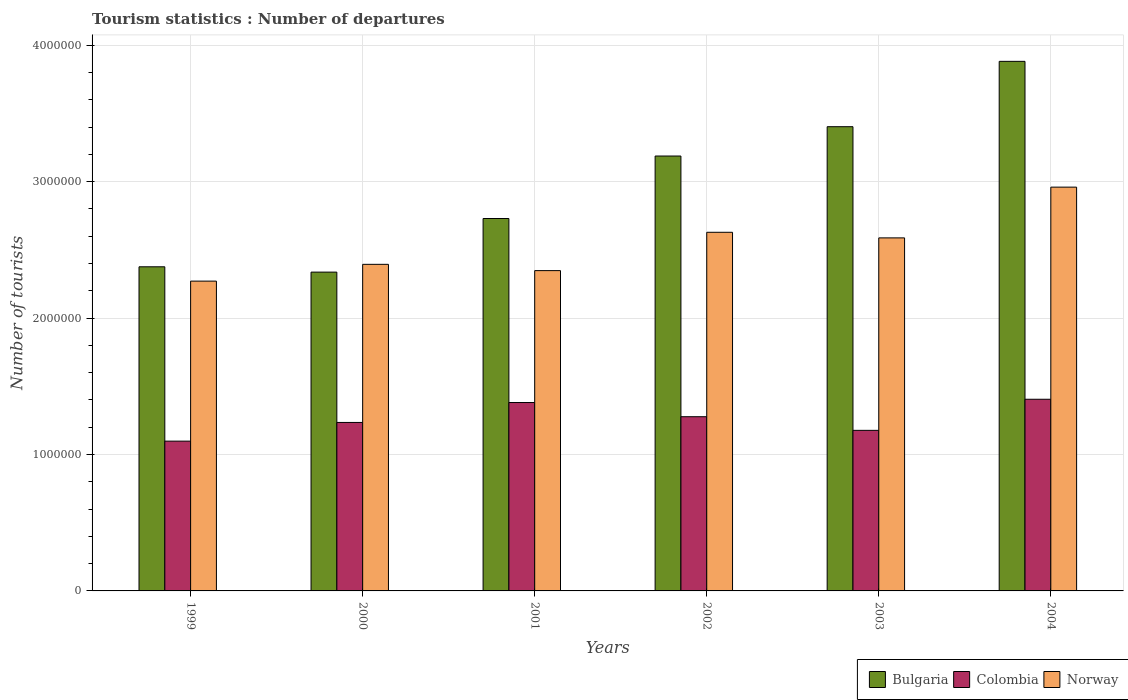Are the number of bars per tick equal to the number of legend labels?
Ensure brevity in your answer.  Yes. How many bars are there on the 6th tick from the left?
Give a very brief answer. 3. What is the label of the 6th group of bars from the left?
Offer a very short reply. 2004. What is the number of tourist departures in Colombia in 2003?
Your answer should be very brief. 1.18e+06. Across all years, what is the maximum number of tourist departures in Colombia?
Ensure brevity in your answer.  1.40e+06. Across all years, what is the minimum number of tourist departures in Norway?
Give a very brief answer. 2.27e+06. In which year was the number of tourist departures in Norway maximum?
Keep it short and to the point. 2004. What is the total number of tourist departures in Bulgaria in the graph?
Make the answer very short. 1.79e+07. What is the difference between the number of tourist departures in Colombia in 1999 and that in 2004?
Keep it short and to the point. -3.07e+05. What is the difference between the number of tourist departures in Colombia in 2002 and the number of tourist departures in Bulgaria in 2004?
Ensure brevity in your answer.  -2.60e+06. What is the average number of tourist departures in Bulgaria per year?
Your answer should be compact. 2.99e+06. In the year 2003, what is the difference between the number of tourist departures in Norway and number of tourist departures in Bulgaria?
Offer a very short reply. -8.15e+05. In how many years, is the number of tourist departures in Colombia greater than 3200000?
Your answer should be very brief. 0. What is the ratio of the number of tourist departures in Norway in 1999 to that in 2001?
Offer a terse response. 0.97. What is the difference between the highest and the second highest number of tourist departures in Colombia?
Ensure brevity in your answer.  2.40e+04. What is the difference between the highest and the lowest number of tourist departures in Norway?
Give a very brief answer. 6.89e+05. Is the sum of the number of tourist departures in Norway in 2003 and 2004 greater than the maximum number of tourist departures in Colombia across all years?
Your answer should be compact. Yes. What does the 2nd bar from the right in 1999 represents?
Offer a very short reply. Colombia. Is it the case that in every year, the sum of the number of tourist departures in Norway and number of tourist departures in Colombia is greater than the number of tourist departures in Bulgaria?
Provide a short and direct response. Yes. How many bars are there?
Provide a succinct answer. 18. Are all the bars in the graph horizontal?
Provide a short and direct response. No. Are the values on the major ticks of Y-axis written in scientific E-notation?
Give a very brief answer. No. Does the graph contain any zero values?
Give a very brief answer. No. Does the graph contain grids?
Your answer should be very brief. Yes. Where does the legend appear in the graph?
Offer a terse response. Bottom right. How are the legend labels stacked?
Your response must be concise. Horizontal. What is the title of the graph?
Offer a terse response. Tourism statistics : Number of departures. Does "Cayman Islands" appear as one of the legend labels in the graph?
Offer a terse response. No. What is the label or title of the Y-axis?
Ensure brevity in your answer.  Number of tourists. What is the Number of tourists in Bulgaria in 1999?
Make the answer very short. 2.38e+06. What is the Number of tourists of Colombia in 1999?
Ensure brevity in your answer.  1.10e+06. What is the Number of tourists of Norway in 1999?
Your answer should be very brief. 2.27e+06. What is the Number of tourists of Bulgaria in 2000?
Provide a succinct answer. 2.34e+06. What is the Number of tourists of Colombia in 2000?
Ensure brevity in your answer.  1.24e+06. What is the Number of tourists of Norway in 2000?
Make the answer very short. 2.39e+06. What is the Number of tourists in Bulgaria in 2001?
Provide a succinct answer. 2.73e+06. What is the Number of tourists in Colombia in 2001?
Your answer should be very brief. 1.38e+06. What is the Number of tourists of Norway in 2001?
Ensure brevity in your answer.  2.35e+06. What is the Number of tourists of Bulgaria in 2002?
Give a very brief answer. 3.19e+06. What is the Number of tourists in Colombia in 2002?
Make the answer very short. 1.28e+06. What is the Number of tourists of Norway in 2002?
Your answer should be very brief. 2.63e+06. What is the Number of tourists of Bulgaria in 2003?
Make the answer very short. 3.40e+06. What is the Number of tourists in Colombia in 2003?
Offer a very short reply. 1.18e+06. What is the Number of tourists in Norway in 2003?
Your answer should be very brief. 2.59e+06. What is the Number of tourists of Bulgaria in 2004?
Provide a short and direct response. 3.88e+06. What is the Number of tourists in Colombia in 2004?
Provide a succinct answer. 1.40e+06. What is the Number of tourists in Norway in 2004?
Your answer should be very brief. 2.96e+06. Across all years, what is the maximum Number of tourists of Bulgaria?
Keep it short and to the point. 3.88e+06. Across all years, what is the maximum Number of tourists in Colombia?
Your response must be concise. 1.40e+06. Across all years, what is the maximum Number of tourists in Norway?
Your response must be concise. 2.96e+06. Across all years, what is the minimum Number of tourists of Bulgaria?
Provide a short and direct response. 2.34e+06. Across all years, what is the minimum Number of tourists in Colombia?
Make the answer very short. 1.10e+06. Across all years, what is the minimum Number of tourists of Norway?
Give a very brief answer. 2.27e+06. What is the total Number of tourists of Bulgaria in the graph?
Offer a terse response. 1.79e+07. What is the total Number of tourists of Colombia in the graph?
Give a very brief answer. 7.57e+06. What is the total Number of tourists in Norway in the graph?
Keep it short and to the point. 1.52e+07. What is the difference between the Number of tourists of Bulgaria in 1999 and that in 2000?
Ensure brevity in your answer.  3.90e+04. What is the difference between the Number of tourists of Colombia in 1999 and that in 2000?
Offer a terse response. -1.37e+05. What is the difference between the Number of tourists of Norway in 1999 and that in 2000?
Ensure brevity in your answer.  -1.23e+05. What is the difference between the Number of tourists in Bulgaria in 1999 and that in 2001?
Your answer should be compact. -3.54e+05. What is the difference between the Number of tourists of Colombia in 1999 and that in 2001?
Your answer should be very brief. -2.83e+05. What is the difference between the Number of tourists in Norway in 1999 and that in 2001?
Give a very brief answer. -7.70e+04. What is the difference between the Number of tourists in Bulgaria in 1999 and that in 2002?
Provide a succinct answer. -8.12e+05. What is the difference between the Number of tourists of Colombia in 1999 and that in 2002?
Your response must be concise. -1.79e+05. What is the difference between the Number of tourists of Norway in 1999 and that in 2002?
Keep it short and to the point. -3.58e+05. What is the difference between the Number of tourists of Bulgaria in 1999 and that in 2003?
Your answer should be compact. -1.03e+06. What is the difference between the Number of tourists in Colombia in 1999 and that in 2003?
Give a very brief answer. -7.90e+04. What is the difference between the Number of tourists of Norway in 1999 and that in 2003?
Make the answer very short. -3.17e+05. What is the difference between the Number of tourists in Bulgaria in 1999 and that in 2004?
Your answer should be compact. -1.51e+06. What is the difference between the Number of tourists in Colombia in 1999 and that in 2004?
Give a very brief answer. -3.07e+05. What is the difference between the Number of tourists in Norway in 1999 and that in 2004?
Offer a very short reply. -6.89e+05. What is the difference between the Number of tourists of Bulgaria in 2000 and that in 2001?
Keep it short and to the point. -3.93e+05. What is the difference between the Number of tourists in Colombia in 2000 and that in 2001?
Your response must be concise. -1.46e+05. What is the difference between the Number of tourists of Norway in 2000 and that in 2001?
Make the answer very short. 4.60e+04. What is the difference between the Number of tourists of Bulgaria in 2000 and that in 2002?
Give a very brief answer. -8.51e+05. What is the difference between the Number of tourists in Colombia in 2000 and that in 2002?
Offer a terse response. -4.20e+04. What is the difference between the Number of tourists of Norway in 2000 and that in 2002?
Your answer should be very brief. -2.35e+05. What is the difference between the Number of tourists of Bulgaria in 2000 and that in 2003?
Provide a short and direct response. -1.07e+06. What is the difference between the Number of tourists of Colombia in 2000 and that in 2003?
Give a very brief answer. 5.80e+04. What is the difference between the Number of tourists in Norway in 2000 and that in 2003?
Ensure brevity in your answer.  -1.94e+05. What is the difference between the Number of tourists in Bulgaria in 2000 and that in 2004?
Keep it short and to the point. -1.54e+06. What is the difference between the Number of tourists of Norway in 2000 and that in 2004?
Provide a short and direct response. -5.66e+05. What is the difference between the Number of tourists in Bulgaria in 2001 and that in 2002?
Ensure brevity in your answer.  -4.58e+05. What is the difference between the Number of tourists of Colombia in 2001 and that in 2002?
Your answer should be compact. 1.04e+05. What is the difference between the Number of tourists of Norway in 2001 and that in 2002?
Provide a succinct answer. -2.81e+05. What is the difference between the Number of tourists of Bulgaria in 2001 and that in 2003?
Ensure brevity in your answer.  -6.73e+05. What is the difference between the Number of tourists in Colombia in 2001 and that in 2003?
Keep it short and to the point. 2.04e+05. What is the difference between the Number of tourists of Bulgaria in 2001 and that in 2004?
Provide a succinct answer. -1.15e+06. What is the difference between the Number of tourists of Colombia in 2001 and that in 2004?
Offer a terse response. -2.40e+04. What is the difference between the Number of tourists of Norway in 2001 and that in 2004?
Your answer should be very brief. -6.12e+05. What is the difference between the Number of tourists of Bulgaria in 2002 and that in 2003?
Provide a succinct answer. -2.15e+05. What is the difference between the Number of tourists of Norway in 2002 and that in 2003?
Provide a succinct answer. 4.10e+04. What is the difference between the Number of tourists in Bulgaria in 2002 and that in 2004?
Keep it short and to the point. -6.94e+05. What is the difference between the Number of tourists of Colombia in 2002 and that in 2004?
Give a very brief answer. -1.28e+05. What is the difference between the Number of tourists of Norway in 2002 and that in 2004?
Provide a short and direct response. -3.31e+05. What is the difference between the Number of tourists in Bulgaria in 2003 and that in 2004?
Ensure brevity in your answer.  -4.79e+05. What is the difference between the Number of tourists in Colombia in 2003 and that in 2004?
Provide a succinct answer. -2.28e+05. What is the difference between the Number of tourists in Norway in 2003 and that in 2004?
Your response must be concise. -3.72e+05. What is the difference between the Number of tourists of Bulgaria in 1999 and the Number of tourists of Colombia in 2000?
Offer a very short reply. 1.14e+06. What is the difference between the Number of tourists of Bulgaria in 1999 and the Number of tourists of Norway in 2000?
Offer a very short reply. -1.80e+04. What is the difference between the Number of tourists of Colombia in 1999 and the Number of tourists of Norway in 2000?
Provide a short and direct response. -1.30e+06. What is the difference between the Number of tourists of Bulgaria in 1999 and the Number of tourists of Colombia in 2001?
Your answer should be very brief. 9.95e+05. What is the difference between the Number of tourists in Bulgaria in 1999 and the Number of tourists in Norway in 2001?
Offer a terse response. 2.80e+04. What is the difference between the Number of tourists in Colombia in 1999 and the Number of tourists in Norway in 2001?
Offer a very short reply. -1.25e+06. What is the difference between the Number of tourists of Bulgaria in 1999 and the Number of tourists of Colombia in 2002?
Provide a short and direct response. 1.10e+06. What is the difference between the Number of tourists of Bulgaria in 1999 and the Number of tourists of Norway in 2002?
Your response must be concise. -2.53e+05. What is the difference between the Number of tourists of Colombia in 1999 and the Number of tourists of Norway in 2002?
Keep it short and to the point. -1.53e+06. What is the difference between the Number of tourists in Bulgaria in 1999 and the Number of tourists in Colombia in 2003?
Offer a terse response. 1.20e+06. What is the difference between the Number of tourists in Bulgaria in 1999 and the Number of tourists in Norway in 2003?
Provide a short and direct response. -2.12e+05. What is the difference between the Number of tourists in Colombia in 1999 and the Number of tourists in Norway in 2003?
Your answer should be compact. -1.49e+06. What is the difference between the Number of tourists of Bulgaria in 1999 and the Number of tourists of Colombia in 2004?
Offer a terse response. 9.71e+05. What is the difference between the Number of tourists of Bulgaria in 1999 and the Number of tourists of Norway in 2004?
Offer a very short reply. -5.84e+05. What is the difference between the Number of tourists in Colombia in 1999 and the Number of tourists in Norway in 2004?
Provide a succinct answer. -1.86e+06. What is the difference between the Number of tourists in Bulgaria in 2000 and the Number of tourists in Colombia in 2001?
Your answer should be compact. 9.56e+05. What is the difference between the Number of tourists in Bulgaria in 2000 and the Number of tourists in Norway in 2001?
Your answer should be very brief. -1.10e+04. What is the difference between the Number of tourists in Colombia in 2000 and the Number of tourists in Norway in 2001?
Give a very brief answer. -1.11e+06. What is the difference between the Number of tourists of Bulgaria in 2000 and the Number of tourists of Colombia in 2002?
Provide a succinct answer. 1.06e+06. What is the difference between the Number of tourists of Bulgaria in 2000 and the Number of tourists of Norway in 2002?
Provide a short and direct response. -2.92e+05. What is the difference between the Number of tourists in Colombia in 2000 and the Number of tourists in Norway in 2002?
Provide a short and direct response. -1.39e+06. What is the difference between the Number of tourists of Bulgaria in 2000 and the Number of tourists of Colombia in 2003?
Give a very brief answer. 1.16e+06. What is the difference between the Number of tourists in Bulgaria in 2000 and the Number of tourists in Norway in 2003?
Your answer should be very brief. -2.51e+05. What is the difference between the Number of tourists of Colombia in 2000 and the Number of tourists of Norway in 2003?
Give a very brief answer. -1.35e+06. What is the difference between the Number of tourists of Bulgaria in 2000 and the Number of tourists of Colombia in 2004?
Offer a terse response. 9.32e+05. What is the difference between the Number of tourists of Bulgaria in 2000 and the Number of tourists of Norway in 2004?
Ensure brevity in your answer.  -6.23e+05. What is the difference between the Number of tourists in Colombia in 2000 and the Number of tourists in Norway in 2004?
Provide a short and direct response. -1.72e+06. What is the difference between the Number of tourists in Bulgaria in 2001 and the Number of tourists in Colombia in 2002?
Offer a terse response. 1.45e+06. What is the difference between the Number of tourists of Bulgaria in 2001 and the Number of tourists of Norway in 2002?
Provide a short and direct response. 1.01e+05. What is the difference between the Number of tourists in Colombia in 2001 and the Number of tourists in Norway in 2002?
Make the answer very short. -1.25e+06. What is the difference between the Number of tourists in Bulgaria in 2001 and the Number of tourists in Colombia in 2003?
Ensure brevity in your answer.  1.55e+06. What is the difference between the Number of tourists in Bulgaria in 2001 and the Number of tourists in Norway in 2003?
Offer a very short reply. 1.42e+05. What is the difference between the Number of tourists of Colombia in 2001 and the Number of tourists of Norway in 2003?
Offer a terse response. -1.21e+06. What is the difference between the Number of tourists in Bulgaria in 2001 and the Number of tourists in Colombia in 2004?
Keep it short and to the point. 1.32e+06. What is the difference between the Number of tourists in Colombia in 2001 and the Number of tourists in Norway in 2004?
Your response must be concise. -1.58e+06. What is the difference between the Number of tourists of Bulgaria in 2002 and the Number of tourists of Colombia in 2003?
Give a very brief answer. 2.01e+06. What is the difference between the Number of tourists in Bulgaria in 2002 and the Number of tourists in Norway in 2003?
Offer a terse response. 6.00e+05. What is the difference between the Number of tourists in Colombia in 2002 and the Number of tourists in Norway in 2003?
Provide a succinct answer. -1.31e+06. What is the difference between the Number of tourists of Bulgaria in 2002 and the Number of tourists of Colombia in 2004?
Keep it short and to the point. 1.78e+06. What is the difference between the Number of tourists of Bulgaria in 2002 and the Number of tourists of Norway in 2004?
Offer a very short reply. 2.28e+05. What is the difference between the Number of tourists in Colombia in 2002 and the Number of tourists in Norway in 2004?
Provide a short and direct response. -1.68e+06. What is the difference between the Number of tourists of Bulgaria in 2003 and the Number of tourists of Colombia in 2004?
Provide a succinct answer. 2.00e+06. What is the difference between the Number of tourists in Bulgaria in 2003 and the Number of tourists in Norway in 2004?
Your answer should be very brief. 4.43e+05. What is the difference between the Number of tourists of Colombia in 2003 and the Number of tourists of Norway in 2004?
Your response must be concise. -1.78e+06. What is the average Number of tourists of Bulgaria per year?
Provide a short and direct response. 2.99e+06. What is the average Number of tourists of Colombia per year?
Provide a succinct answer. 1.26e+06. What is the average Number of tourists of Norway per year?
Provide a short and direct response. 2.53e+06. In the year 1999, what is the difference between the Number of tourists in Bulgaria and Number of tourists in Colombia?
Provide a short and direct response. 1.28e+06. In the year 1999, what is the difference between the Number of tourists in Bulgaria and Number of tourists in Norway?
Offer a very short reply. 1.05e+05. In the year 1999, what is the difference between the Number of tourists of Colombia and Number of tourists of Norway?
Provide a short and direct response. -1.17e+06. In the year 2000, what is the difference between the Number of tourists in Bulgaria and Number of tourists in Colombia?
Your response must be concise. 1.10e+06. In the year 2000, what is the difference between the Number of tourists of Bulgaria and Number of tourists of Norway?
Offer a very short reply. -5.70e+04. In the year 2000, what is the difference between the Number of tourists in Colombia and Number of tourists in Norway?
Provide a succinct answer. -1.16e+06. In the year 2001, what is the difference between the Number of tourists of Bulgaria and Number of tourists of Colombia?
Offer a very short reply. 1.35e+06. In the year 2001, what is the difference between the Number of tourists in Bulgaria and Number of tourists in Norway?
Give a very brief answer. 3.82e+05. In the year 2001, what is the difference between the Number of tourists in Colombia and Number of tourists in Norway?
Provide a short and direct response. -9.67e+05. In the year 2002, what is the difference between the Number of tourists of Bulgaria and Number of tourists of Colombia?
Offer a terse response. 1.91e+06. In the year 2002, what is the difference between the Number of tourists in Bulgaria and Number of tourists in Norway?
Your response must be concise. 5.59e+05. In the year 2002, what is the difference between the Number of tourists in Colombia and Number of tourists in Norway?
Keep it short and to the point. -1.35e+06. In the year 2003, what is the difference between the Number of tourists in Bulgaria and Number of tourists in Colombia?
Keep it short and to the point. 2.23e+06. In the year 2003, what is the difference between the Number of tourists in Bulgaria and Number of tourists in Norway?
Your answer should be compact. 8.15e+05. In the year 2003, what is the difference between the Number of tourists in Colombia and Number of tourists in Norway?
Make the answer very short. -1.41e+06. In the year 2004, what is the difference between the Number of tourists in Bulgaria and Number of tourists in Colombia?
Ensure brevity in your answer.  2.48e+06. In the year 2004, what is the difference between the Number of tourists in Bulgaria and Number of tourists in Norway?
Offer a terse response. 9.22e+05. In the year 2004, what is the difference between the Number of tourists of Colombia and Number of tourists of Norway?
Your answer should be very brief. -1.56e+06. What is the ratio of the Number of tourists of Bulgaria in 1999 to that in 2000?
Offer a very short reply. 1.02. What is the ratio of the Number of tourists in Colombia in 1999 to that in 2000?
Give a very brief answer. 0.89. What is the ratio of the Number of tourists of Norway in 1999 to that in 2000?
Your response must be concise. 0.95. What is the ratio of the Number of tourists of Bulgaria in 1999 to that in 2001?
Ensure brevity in your answer.  0.87. What is the ratio of the Number of tourists in Colombia in 1999 to that in 2001?
Offer a very short reply. 0.8. What is the ratio of the Number of tourists in Norway in 1999 to that in 2001?
Provide a succinct answer. 0.97. What is the ratio of the Number of tourists of Bulgaria in 1999 to that in 2002?
Ensure brevity in your answer.  0.75. What is the ratio of the Number of tourists in Colombia in 1999 to that in 2002?
Provide a succinct answer. 0.86. What is the ratio of the Number of tourists of Norway in 1999 to that in 2002?
Offer a terse response. 0.86. What is the ratio of the Number of tourists of Bulgaria in 1999 to that in 2003?
Make the answer very short. 0.7. What is the ratio of the Number of tourists in Colombia in 1999 to that in 2003?
Keep it short and to the point. 0.93. What is the ratio of the Number of tourists in Norway in 1999 to that in 2003?
Give a very brief answer. 0.88. What is the ratio of the Number of tourists in Bulgaria in 1999 to that in 2004?
Ensure brevity in your answer.  0.61. What is the ratio of the Number of tourists of Colombia in 1999 to that in 2004?
Offer a terse response. 0.78. What is the ratio of the Number of tourists of Norway in 1999 to that in 2004?
Provide a succinct answer. 0.77. What is the ratio of the Number of tourists in Bulgaria in 2000 to that in 2001?
Offer a terse response. 0.86. What is the ratio of the Number of tourists of Colombia in 2000 to that in 2001?
Ensure brevity in your answer.  0.89. What is the ratio of the Number of tourists of Norway in 2000 to that in 2001?
Make the answer very short. 1.02. What is the ratio of the Number of tourists in Bulgaria in 2000 to that in 2002?
Keep it short and to the point. 0.73. What is the ratio of the Number of tourists in Colombia in 2000 to that in 2002?
Your answer should be very brief. 0.97. What is the ratio of the Number of tourists in Norway in 2000 to that in 2002?
Your response must be concise. 0.91. What is the ratio of the Number of tourists in Bulgaria in 2000 to that in 2003?
Give a very brief answer. 0.69. What is the ratio of the Number of tourists in Colombia in 2000 to that in 2003?
Provide a succinct answer. 1.05. What is the ratio of the Number of tourists in Norway in 2000 to that in 2003?
Offer a terse response. 0.93. What is the ratio of the Number of tourists in Bulgaria in 2000 to that in 2004?
Offer a terse response. 0.6. What is the ratio of the Number of tourists of Colombia in 2000 to that in 2004?
Provide a short and direct response. 0.88. What is the ratio of the Number of tourists of Norway in 2000 to that in 2004?
Ensure brevity in your answer.  0.81. What is the ratio of the Number of tourists in Bulgaria in 2001 to that in 2002?
Your answer should be very brief. 0.86. What is the ratio of the Number of tourists in Colombia in 2001 to that in 2002?
Keep it short and to the point. 1.08. What is the ratio of the Number of tourists in Norway in 2001 to that in 2002?
Your answer should be compact. 0.89. What is the ratio of the Number of tourists of Bulgaria in 2001 to that in 2003?
Your answer should be very brief. 0.8. What is the ratio of the Number of tourists of Colombia in 2001 to that in 2003?
Your answer should be very brief. 1.17. What is the ratio of the Number of tourists in Norway in 2001 to that in 2003?
Offer a very short reply. 0.91. What is the ratio of the Number of tourists in Bulgaria in 2001 to that in 2004?
Keep it short and to the point. 0.7. What is the ratio of the Number of tourists of Colombia in 2001 to that in 2004?
Ensure brevity in your answer.  0.98. What is the ratio of the Number of tourists of Norway in 2001 to that in 2004?
Offer a terse response. 0.79. What is the ratio of the Number of tourists in Bulgaria in 2002 to that in 2003?
Your answer should be compact. 0.94. What is the ratio of the Number of tourists in Colombia in 2002 to that in 2003?
Offer a terse response. 1.08. What is the ratio of the Number of tourists of Norway in 2002 to that in 2003?
Keep it short and to the point. 1.02. What is the ratio of the Number of tourists in Bulgaria in 2002 to that in 2004?
Your answer should be very brief. 0.82. What is the ratio of the Number of tourists in Colombia in 2002 to that in 2004?
Ensure brevity in your answer.  0.91. What is the ratio of the Number of tourists of Norway in 2002 to that in 2004?
Provide a short and direct response. 0.89. What is the ratio of the Number of tourists in Bulgaria in 2003 to that in 2004?
Ensure brevity in your answer.  0.88. What is the ratio of the Number of tourists in Colombia in 2003 to that in 2004?
Your answer should be compact. 0.84. What is the ratio of the Number of tourists of Norway in 2003 to that in 2004?
Keep it short and to the point. 0.87. What is the difference between the highest and the second highest Number of tourists of Bulgaria?
Make the answer very short. 4.79e+05. What is the difference between the highest and the second highest Number of tourists in Colombia?
Give a very brief answer. 2.40e+04. What is the difference between the highest and the second highest Number of tourists in Norway?
Ensure brevity in your answer.  3.31e+05. What is the difference between the highest and the lowest Number of tourists in Bulgaria?
Your answer should be very brief. 1.54e+06. What is the difference between the highest and the lowest Number of tourists in Colombia?
Provide a short and direct response. 3.07e+05. What is the difference between the highest and the lowest Number of tourists in Norway?
Ensure brevity in your answer.  6.89e+05. 